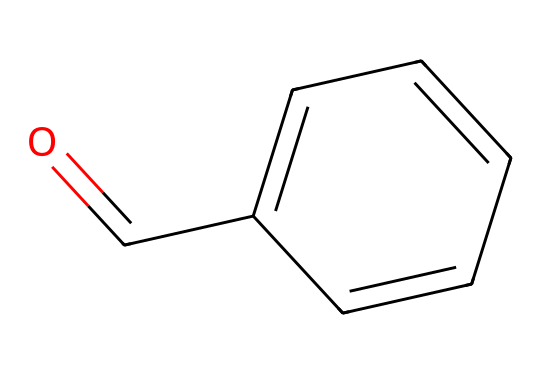What is the functional group present in benzaldehyde? The structure shows a carbonyl group (C=O) directly linked to a benzene ring, which identifies it as an aldehyde.
Answer: aldehyde How many carbon atoms are in benzaldehyde? The SMILES representation indicates that there are six carbon atoms in the benzene ring and one carbon in the carbonyl group, totaling seven carbon atoms.
Answer: seven What is the molecular formula of benzaldehyde? The structure includes six carbon atoms (C), five hydrogen atoms (H), and one oxygen atom (O), leading to the molecular formula C7H6O.
Answer: C7H6O Is benzaldehyde aromatic? The presence of a benzene ring in its structure, which is a hallmark of aromatic compounds, confirms that benzaldehyde is indeed aromatic.
Answer: yes Which type of reaction commonly involves benzaldehyde? Benzaldehyde is often involved in nucleophilic addition reactions due to the electrophilic nature of the carbonyl carbon.
Answer: nucleophilic addition How many rings are present in the structure of benzaldehyde? The structure depicts a single benzene ring, indicating that there is only one ring in benzaldehyde.
Answer: one What role does benzaldehyde play in flavoring? Benzaldehyde imparts a sweet almond flavor, commonly used in food products, notably in almond-flavored biscuits.
Answer: flavoring 